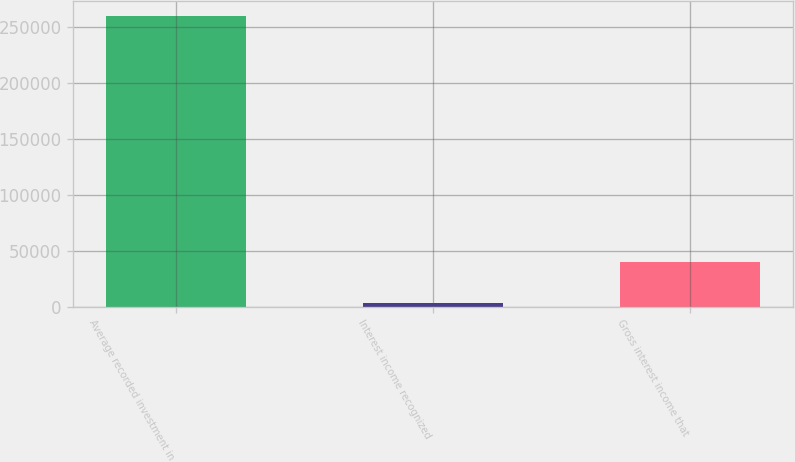<chart> <loc_0><loc_0><loc_500><loc_500><bar_chart><fcel>Average recorded investment in<fcel>Interest income recognized<fcel>Gross interest income that<nl><fcel>260251<fcel>2946<fcel>39917<nl></chart> 